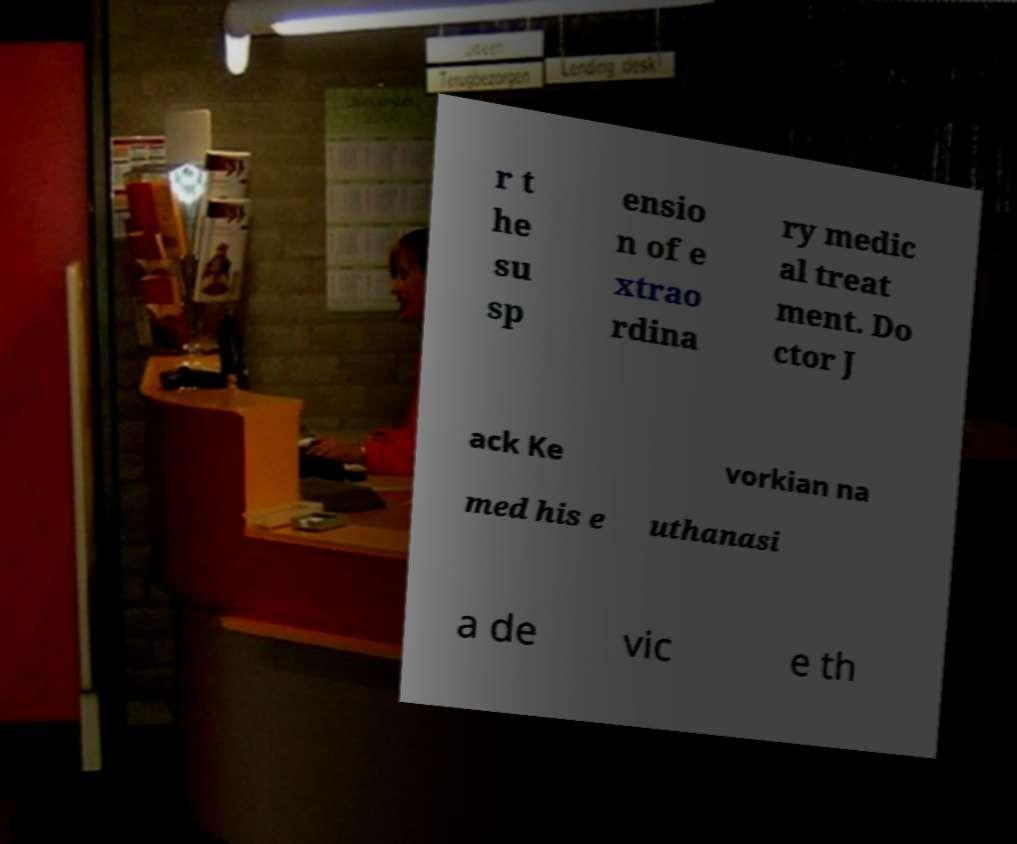Please identify and transcribe the text found in this image. r t he su sp ensio n of e xtrao rdina ry medic al treat ment. Do ctor J ack Ke vorkian na med his e uthanasi a de vic e th 